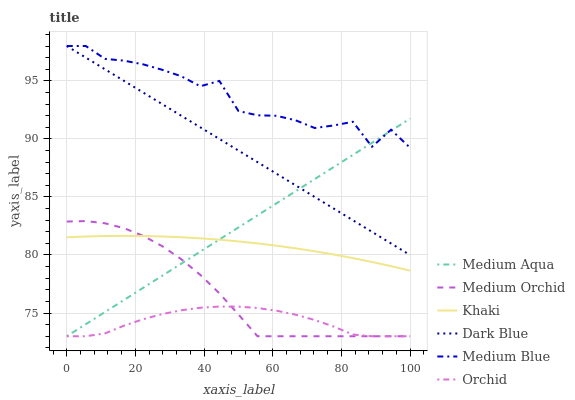Does Orchid have the minimum area under the curve?
Answer yes or no. Yes. Does Medium Blue have the maximum area under the curve?
Answer yes or no. Yes. Does Medium Orchid have the minimum area under the curve?
Answer yes or no. No. Does Medium Orchid have the maximum area under the curve?
Answer yes or no. No. Is Dark Blue the smoothest?
Answer yes or no. Yes. Is Medium Blue the roughest?
Answer yes or no. Yes. Is Medium Orchid the smoothest?
Answer yes or no. No. Is Medium Orchid the roughest?
Answer yes or no. No. Does Medium Blue have the lowest value?
Answer yes or no. No. Does Medium Orchid have the highest value?
Answer yes or no. No. Is Orchid less than Khaki?
Answer yes or no. Yes. Is Medium Blue greater than Orchid?
Answer yes or no. Yes. Does Orchid intersect Khaki?
Answer yes or no. No. 